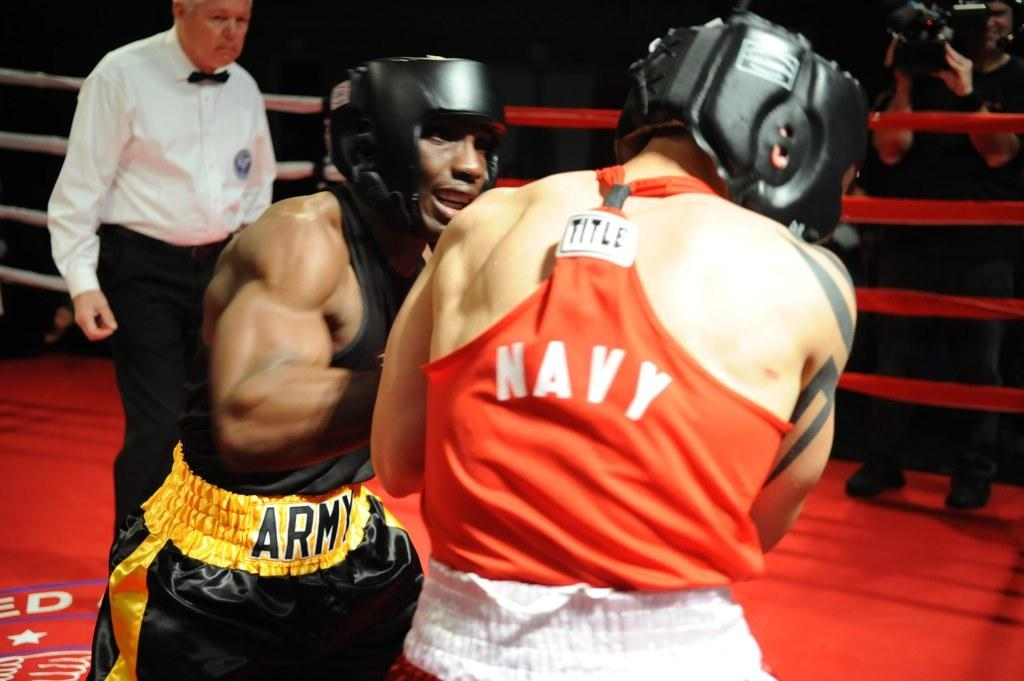<image>
Render a clear and concise summary of the photo. A man in black and gold Army shorts boxes with a man in an orange Navy shirt 